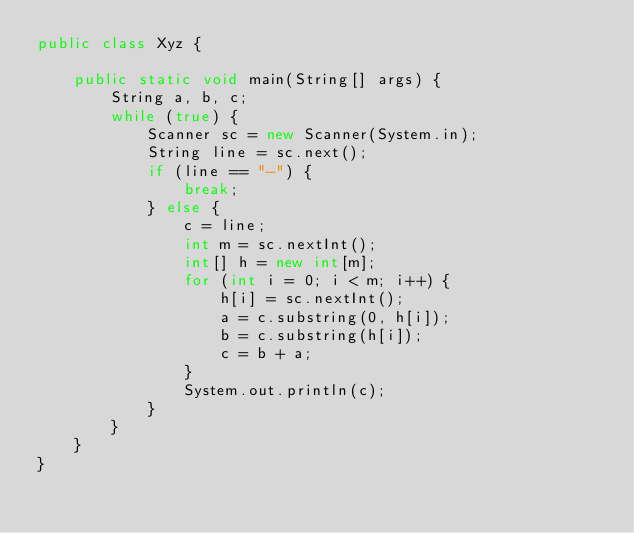Convert code to text. <code><loc_0><loc_0><loc_500><loc_500><_Java_>public class Xyz {

	public static void main(String[] args) {
		String a, b, c;
		while (true) {
			Scanner sc = new Scanner(System.in);
			String line = sc.next();
			if (line == "-") {
				break;
			} else {
				c = line;
				int m = sc.nextInt();
				int[] h = new int[m];
				for (int i = 0; i < m; i++) {
					h[i] = sc.nextInt();
					a = c.substring(0, h[i]);
					b = c.substring(h[i]);
					c = b + a;
				}
				System.out.println(c);
			}
		}
	}
}</code> 